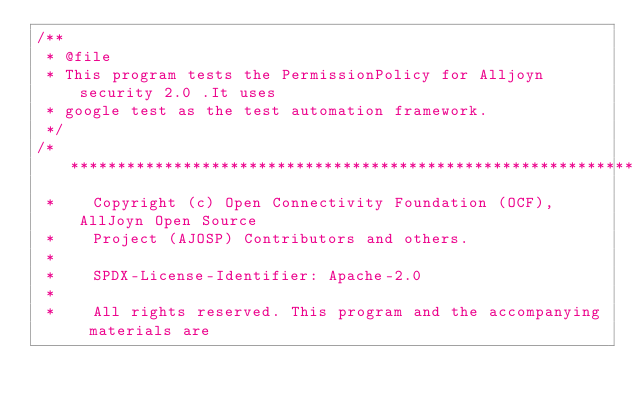<code> <loc_0><loc_0><loc_500><loc_500><_C++_>/**
 * @file
 * This program tests the PermissionPolicy for Alljoyn security 2.0 .It uses
 * google test as the test automation framework.
 */
/******************************************************************************
 *    Copyright (c) Open Connectivity Foundation (OCF), AllJoyn Open Source
 *    Project (AJOSP) Contributors and others.
 *
 *    SPDX-License-Identifier: Apache-2.0
 *
 *    All rights reserved. This program and the accompanying materials are</code> 